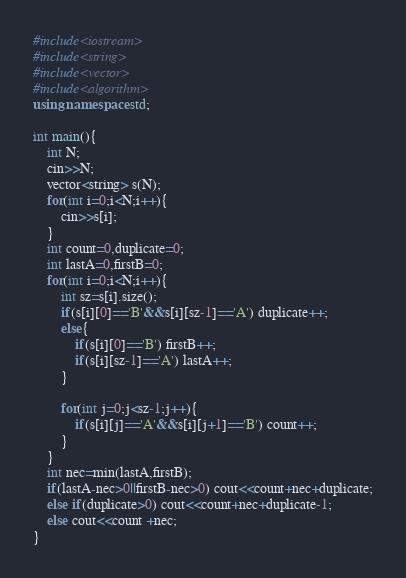Convert code to text. <code><loc_0><loc_0><loc_500><loc_500><_C++_>#include<iostream>
#include<string>
#include<vector>
#include<algorithm>
using namespace std;

int main(){
	int N;
	cin>>N;
	vector<string> s(N);
	for(int i=0;i<N;i++){
		cin>>s[i];
	}
	int count=0,duplicate=0;
	int lastA=0,firstB=0;
	for(int i=0;i<N;i++){
		int sz=s[i].size();
		if(s[i][0]=='B'&&s[i][sz-1]=='A') duplicate++;
		else{
			if(s[i][0]=='B') firstB++;
		    if(s[i][sz-1]=='A') lastA++;
		}
		
		for(int j=0;j<sz-1;j++){
			if(s[i][j]=='A'&&s[i][j+1]=='B') count++;
		}
	}
	int nec=min(lastA,firstB);
	if(lastA-nec>0||firstB-nec>0) cout<<count+nec+duplicate;
	else if(duplicate>0) cout<<count+nec+duplicate-1;
	else cout<<count +nec;
}</code> 